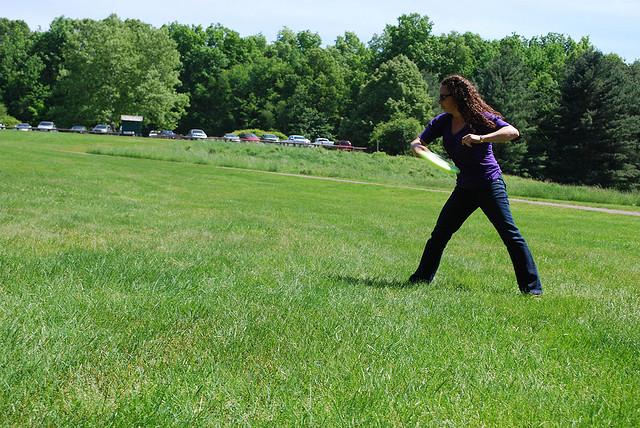Is the lady involved in competition?
Concise answer only. No. Can a flying Frisbee break a window?
Concise answer only. Yes. Is this woman throwing something?
Concise answer only. Yes. What kind of sport is this?
Give a very brief answer. Frisbee. 